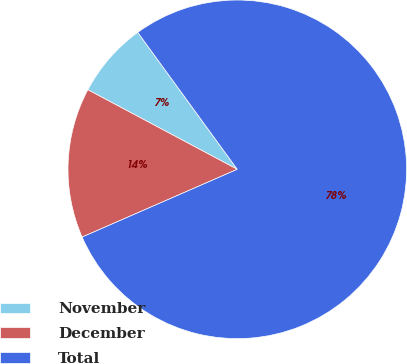<chart> <loc_0><loc_0><loc_500><loc_500><pie_chart><fcel>November<fcel>December<fcel>Total<nl><fcel>7.21%<fcel>14.34%<fcel>78.45%<nl></chart> 